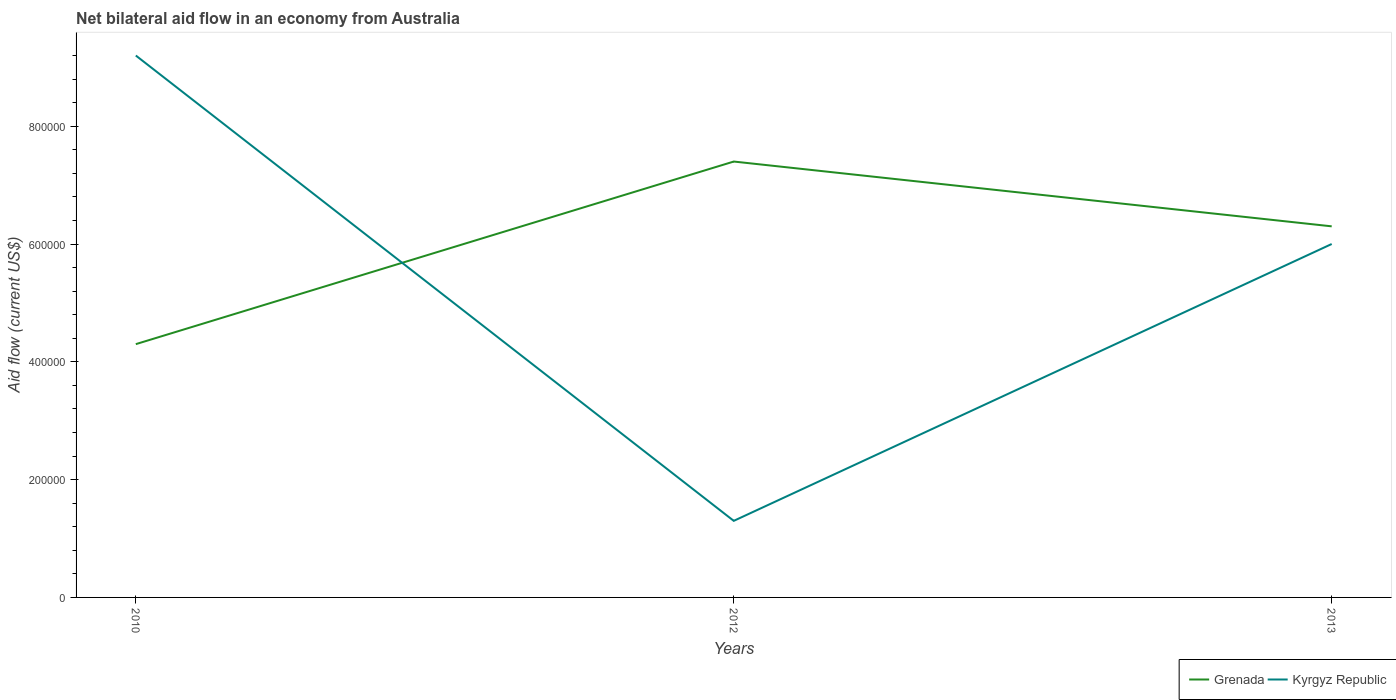In which year was the net bilateral aid flow in Kyrgyz Republic maximum?
Give a very brief answer. 2012. What is the total net bilateral aid flow in Kyrgyz Republic in the graph?
Offer a very short reply. 7.90e+05. What is the difference between the highest and the lowest net bilateral aid flow in Kyrgyz Republic?
Offer a terse response. 2. How many lines are there?
Offer a terse response. 2. What is the difference between two consecutive major ticks on the Y-axis?
Ensure brevity in your answer.  2.00e+05. Are the values on the major ticks of Y-axis written in scientific E-notation?
Your response must be concise. No. Where does the legend appear in the graph?
Offer a very short reply. Bottom right. How are the legend labels stacked?
Give a very brief answer. Horizontal. What is the title of the graph?
Offer a terse response. Net bilateral aid flow in an economy from Australia. What is the label or title of the X-axis?
Provide a succinct answer. Years. What is the Aid flow (current US$) of Grenada in 2010?
Your response must be concise. 4.30e+05. What is the Aid flow (current US$) of Kyrgyz Republic in 2010?
Ensure brevity in your answer.  9.20e+05. What is the Aid flow (current US$) of Grenada in 2012?
Give a very brief answer. 7.40e+05. What is the Aid flow (current US$) in Kyrgyz Republic in 2012?
Offer a terse response. 1.30e+05. What is the Aid flow (current US$) of Grenada in 2013?
Offer a very short reply. 6.30e+05. Across all years, what is the maximum Aid flow (current US$) of Grenada?
Ensure brevity in your answer.  7.40e+05. Across all years, what is the maximum Aid flow (current US$) of Kyrgyz Republic?
Keep it short and to the point. 9.20e+05. Across all years, what is the minimum Aid flow (current US$) of Grenada?
Your answer should be compact. 4.30e+05. What is the total Aid flow (current US$) in Grenada in the graph?
Provide a short and direct response. 1.80e+06. What is the total Aid flow (current US$) of Kyrgyz Republic in the graph?
Make the answer very short. 1.65e+06. What is the difference between the Aid flow (current US$) in Grenada in 2010 and that in 2012?
Your answer should be compact. -3.10e+05. What is the difference between the Aid flow (current US$) of Kyrgyz Republic in 2010 and that in 2012?
Offer a very short reply. 7.90e+05. What is the difference between the Aid flow (current US$) of Grenada in 2010 and that in 2013?
Make the answer very short. -2.00e+05. What is the difference between the Aid flow (current US$) of Kyrgyz Republic in 2010 and that in 2013?
Your answer should be very brief. 3.20e+05. What is the difference between the Aid flow (current US$) of Grenada in 2012 and that in 2013?
Your answer should be very brief. 1.10e+05. What is the difference between the Aid flow (current US$) in Kyrgyz Republic in 2012 and that in 2013?
Your answer should be compact. -4.70e+05. What is the difference between the Aid flow (current US$) in Grenada in 2010 and the Aid flow (current US$) in Kyrgyz Republic in 2013?
Offer a very short reply. -1.70e+05. What is the average Aid flow (current US$) in Grenada per year?
Offer a very short reply. 6.00e+05. What is the average Aid flow (current US$) of Kyrgyz Republic per year?
Provide a succinct answer. 5.50e+05. In the year 2010, what is the difference between the Aid flow (current US$) of Grenada and Aid flow (current US$) of Kyrgyz Republic?
Make the answer very short. -4.90e+05. In the year 2012, what is the difference between the Aid flow (current US$) of Grenada and Aid flow (current US$) of Kyrgyz Republic?
Provide a succinct answer. 6.10e+05. What is the ratio of the Aid flow (current US$) in Grenada in 2010 to that in 2012?
Make the answer very short. 0.58. What is the ratio of the Aid flow (current US$) in Kyrgyz Republic in 2010 to that in 2012?
Your answer should be very brief. 7.08. What is the ratio of the Aid flow (current US$) of Grenada in 2010 to that in 2013?
Your answer should be very brief. 0.68. What is the ratio of the Aid flow (current US$) in Kyrgyz Republic in 2010 to that in 2013?
Provide a succinct answer. 1.53. What is the ratio of the Aid flow (current US$) in Grenada in 2012 to that in 2013?
Make the answer very short. 1.17. What is the ratio of the Aid flow (current US$) in Kyrgyz Republic in 2012 to that in 2013?
Make the answer very short. 0.22. What is the difference between the highest and the lowest Aid flow (current US$) of Grenada?
Offer a terse response. 3.10e+05. What is the difference between the highest and the lowest Aid flow (current US$) of Kyrgyz Republic?
Make the answer very short. 7.90e+05. 